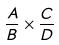Convert formula to latex. <formula><loc_0><loc_0><loc_500><loc_500>\frac { A } { B } \times \frac { C } { D }</formula> 